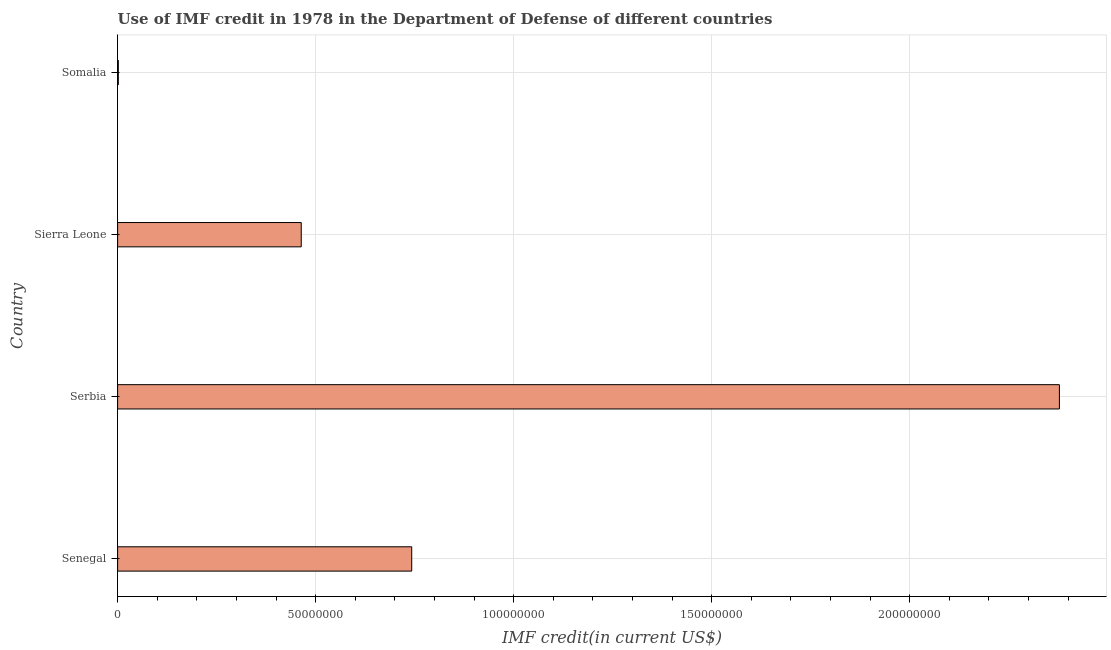Does the graph contain grids?
Offer a very short reply. Yes. What is the title of the graph?
Your answer should be compact. Use of IMF credit in 1978 in the Department of Defense of different countries. What is the label or title of the X-axis?
Provide a succinct answer. IMF credit(in current US$). What is the label or title of the Y-axis?
Provide a short and direct response. Country. What is the use of imf credit in dod in Senegal?
Offer a very short reply. 7.43e+07. Across all countries, what is the maximum use of imf credit in dod?
Give a very brief answer. 2.38e+08. Across all countries, what is the minimum use of imf credit in dod?
Keep it short and to the point. 1.82e+05. In which country was the use of imf credit in dod maximum?
Offer a very short reply. Serbia. In which country was the use of imf credit in dod minimum?
Keep it short and to the point. Somalia. What is the sum of the use of imf credit in dod?
Your answer should be very brief. 3.59e+08. What is the difference between the use of imf credit in dod in Senegal and Serbia?
Your answer should be very brief. -1.64e+08. What is the average use of imf credit in dod per country?
Your response must be concise. 8.97e+07. What is the median use of imf credit in dod?
Your answer should be very brief. 6.03e+07. In how many countries, is the use of imf credit in dod greater than 180000000 US$?
Offer a very short reply. 1. What is the ratio of the use of imf credit in dod in Serbia to that in Sierra Leone?
Your response must be concise. 5.13. Is the difference between the use of imf credit in dod in Serbia and Somalia greater than the difference between any two countries?
Ensure brevity in your answer.  Yes. What is the difference between the highest and the second highest use of imf credit in dod?
Give a very brief answer. 1.64e+08. What is the difference between the highest and the lowest use of imf credit in dod?
Offer a very short reply. 2.38e+08. How many bars are there?
Provide a succinct answer. 4. How many countries are there in the graph?
Keep it short and to the point. 4. What is the difference between two consecutive major ticks on the X-axis?
Your response must be concise. 5.00e+07. Are the values on the major ticks of X-axis written in scientific E-notation?
Offer a terse response. No. What is the IMF credit(in current US$) in Senegal?
Provide a short and direct response. 7.43e+07. What is the IMF credit(in current US$) in Serbia?
Your answer should be very brief. 2.38e+08. What is the IMF credit(in current US$) of Sierra Leone?
Your answer should be compact. 4.64e+07. What is the IMF credit(in current US$) of Somalia?
Give a very brief answer. 1.82e+05. What is the difference between the IMF credit(in current US$) in Senegal and Serbia?
Your answer should be compact. -1.64e+08. What is the difference between the IMF credit(in current US$) in Senegal and Sierra Leone?
Offer a very short reply. 2.79e+07. What is the difference between the IMF credit(in current US$) in Senegal and Somalia?
Your answer should be very brief. 7.41e+07. What is the difference between the IMF credit(in current US$) in Serbia and Sierra Leone?
Provide a succinct answer. 1.91e+08. What is the difference between the IMF credit(in current US$) in Serbia and Somalia?
Make the answer very short. 2.38e+08. What is the difference between the IMF credit(in current US$) in Sierra Leone and Somalia?
Your answer should be very brief. 4.62e+07. What is the ratio of the IMF credit(in current US$) in Senegal to that in Serbia?
Ensure brevity in your answer.  0.31. What is the ratio of the IMF credit(in current US$) in Senegal to that in Sierra Leone?
Your answer should be compact. 1.6. What is the ratio of the IMF credit(in current US$) in Senegal to that in Somalia?
Offer a terse response. 408.03. What is the ratio of the IMF credit(in current US$) in Serbia to that in Sierra Leone?
Provide a succinct answer. 5.13. What is the ratio of the IMF credit(in current US$) in Serbia to that in Somalia?
Your response must be concise. 1306.59. What is the ratio of the IMF credit(in current US$) in Sierra Leone to that in Somalia?
Give a very brief answer. 254.78. 